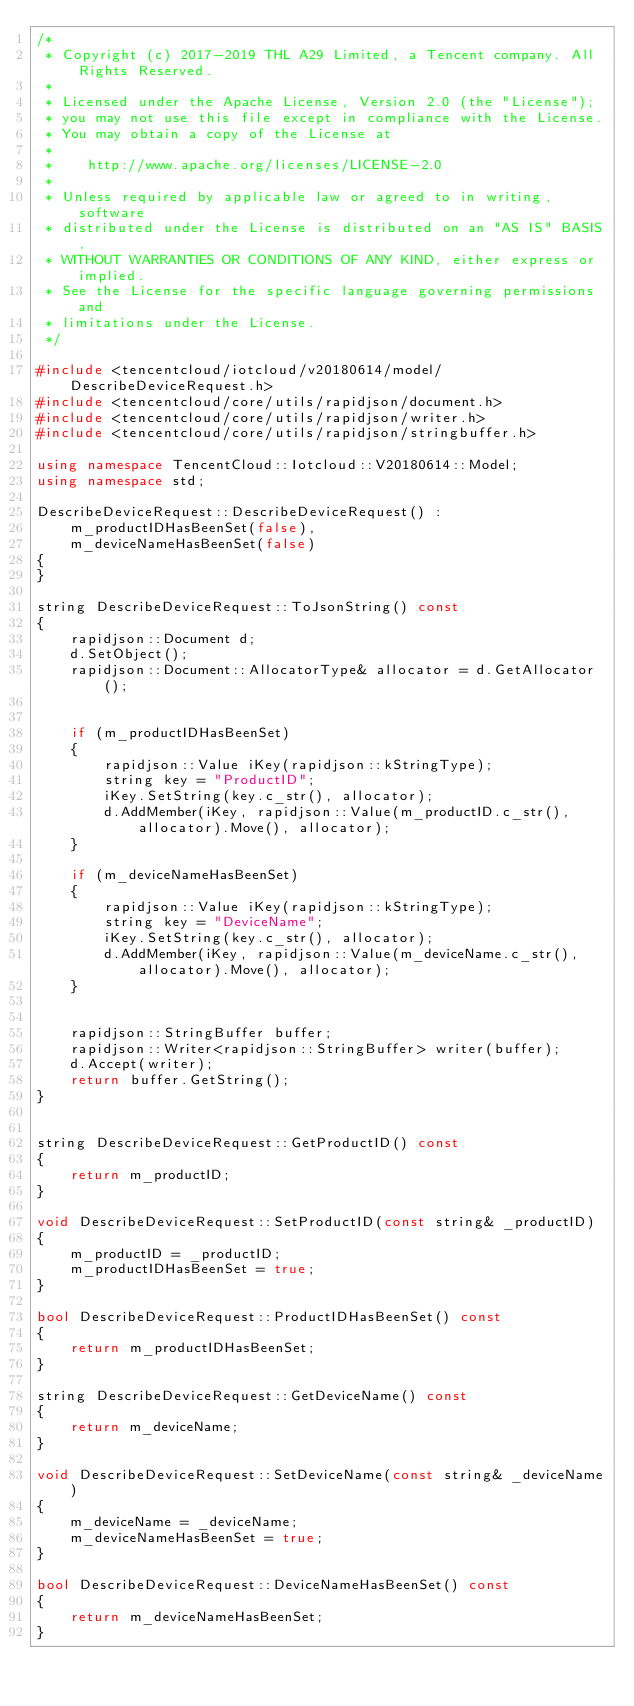Convert code to text. <code><loc_0><loc_0><loc_500><loc_500><_C++_>/*
 * Copyright (c) 2017-2019 THL A29 Limited, a Tencent company. All Rights Reserved.
 *
 * Licensed under the Apache License, Version 2.0 (the "License");
 * you may not use this file except in compliance with the License.
 * You may obtain a copy of the License at
 *
 *    http://www.apache.org/licenses/LICENSE-2.0
 *
 * Unless required by applicable law or agreed to in writing, software
 * distributed under the License is distributed on an "AS IS" BASIS,
 * WITHOUT WARRANTIES OR CONDITIONS OF ANY KIND, either express or implied.
 * See the License for the specific language governing permissions and
 * limitations under the License.
 */

#include <tencentcloud/iotcloud/v20180614/model/DescribeDeviceRequest.h>
#include <tencentcloud/core/utils/rapidjson/document.h>
#include <tencentcloud/core/utils/rapidjson/writer.h>
#include <tencentcloud/core/utils/rapidjson/stringbuffer.h>

using namespace TencentCloud::Iotcloud::V20180614::Model;
using namespace std;

DescribeDeviceRequest::DescribeDeviceRequest() :
    m_productIDHasBeenSet(false),
    m_deviceNameHasBeenSet(false)
{
}

string DescribeDeviceRequest::ToJsonString() const
{
    rapidjson::Document d;
    d.SetObject();
    rapidjson::Document::AllocatorType& allocator = d.GetAllocator();


    if (m_productIDHasBeenSet)
    {
        rapidjson::Value iKey(rapidjson::kStringType);
        string key = "ProductID";
        iKey.SetString(key.c_str(), allocator);
        d.AddMember(iKey, rapidjson::Value(m_productID.c_str(), allocator).Move(), allocator);
    }

    if (m_deviceNameHasBeenSet)
    {
        rapidjson::Value iKey(rapidjson::kStringType);
        string key = "DeviceName";
        iKey.SetString(key.c_str(), allocator);
        d.AddMember(iKey, rapidjson::Value(m_deviceName.c_str(), allocator).Move(), allocator);
    }


    rapidjson::StringBuffer buffer;
    rapidjson::Writer<rapidjson::StringBuffer> writer(buffer);
    d.Accept(writer);
    return buffer.GetString();
}


string DescribeDeviceRequest::GetProductID() const
{
    return m_productID;
}

void DescribeDeviceRequest::SetProductID(const string& _productID)
{
    m_productID = _productID;
    m_productIDHasBeenSet = true;
}

bool DescribeDeviceRequest::ProductIDHasBeenSet() const
{
    return m_productIDHasBeenSet;
}

string DescribeDeviceRequest::GetDeviceName() const
{
    return m_deviceName;
}

void DescribeDeviceRequest::SetDeviceName(const string& _deviceName)
{
    m_deviceName = _deviceName;
    m_deviceNameHasBeenSet = true;
}

bool DescribeDeviceRequest::DeviceNameHasBeenSet() const
{
    return m_deviceNameHasBeenSet;
}


</code> 